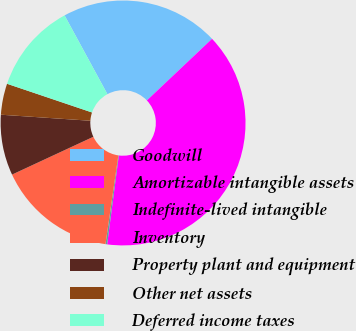<chart> <loc_0><loc_0><loc_500><loc_500><pie_chart><fcel>Goodwill<fcel>Amortizable intangible assets<fcel>Indefinite-lived intangible<fcel>Inventory<fcel>Property plant and equipment<fcel>Other net assets<fcel>Deferred income taxes<nl><fcel>20.87%<fcel>39.13%<fcel>0.22%<fcel>15.78%<fcel>8.0%<fcel>4.11%<fcel>11.89%<nl></chart> 